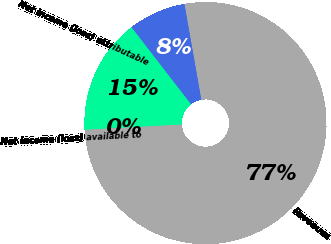<chart> <loc_0><loc_0><loc_500><loc_500><pie_chart><fcel>Revenues<fcel>Income (loss) from continuing<fcel>Net income (loss) attributable<fcel>Net income (loss) available to<nl><fcel>76.92%<fcel>7.69%<fcel>15.39%<fcel>0.0%<nl></chart> 